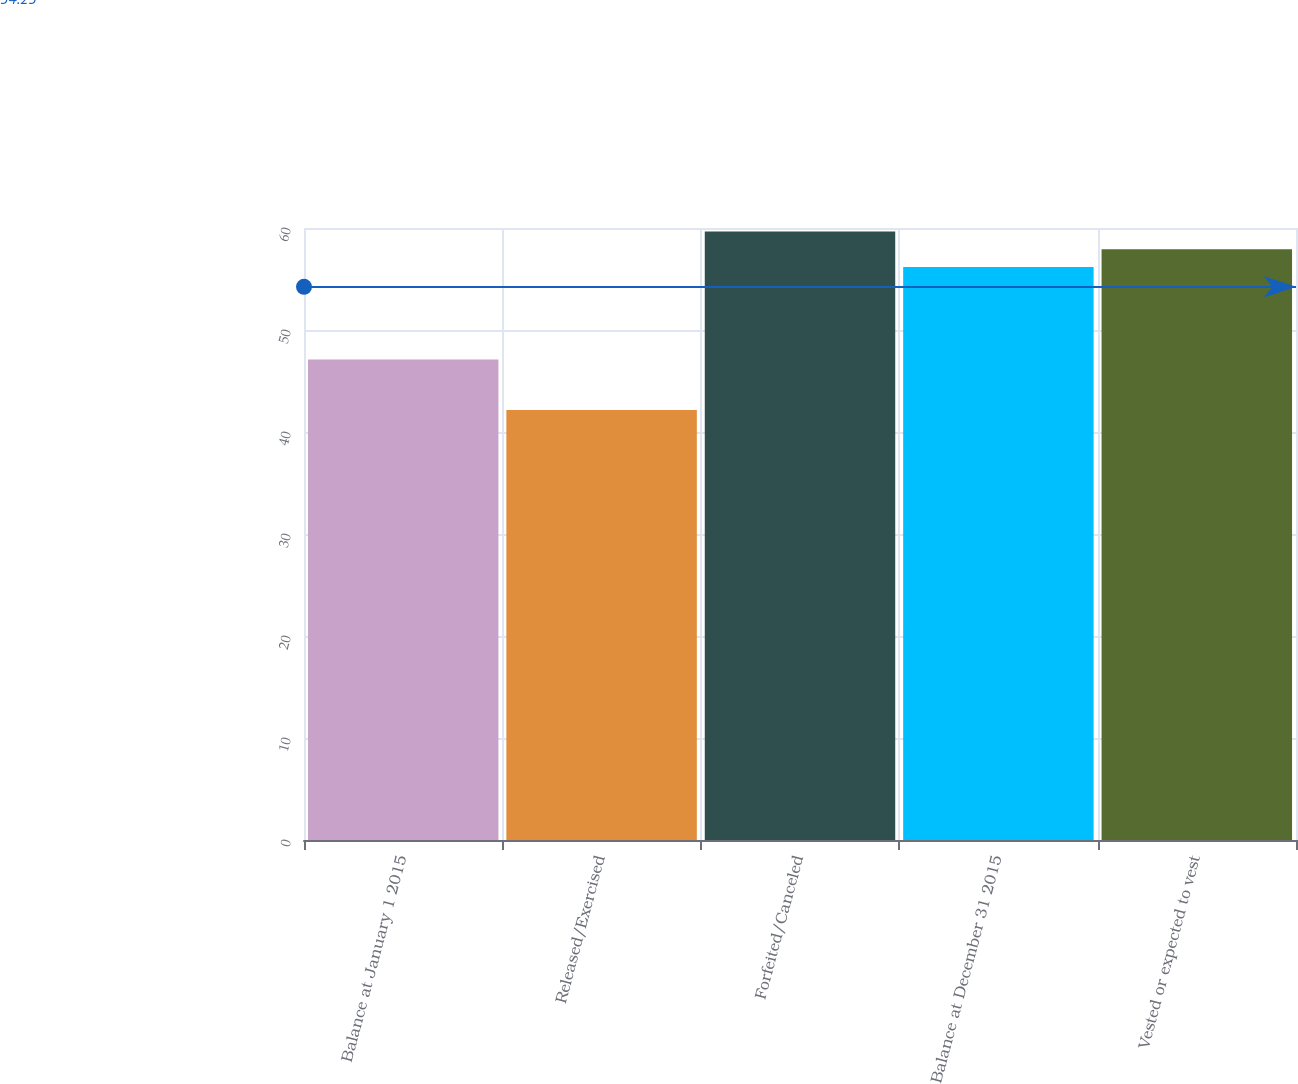Convert chart. <chart><loc_0><loc_0><loc_500><loc_500><bar_chart><fcel>Balance at January 1 2015<fcel>Released/Exercised<fcel>Forfeited/Canceled<fcel>Balance at December 31 2015<fcel>Vested or expected to vest<nl><fcel>47.12<fcel>42.15<fcel>59.65<fcel>56.17<fcel>57.91<nl></chart> 